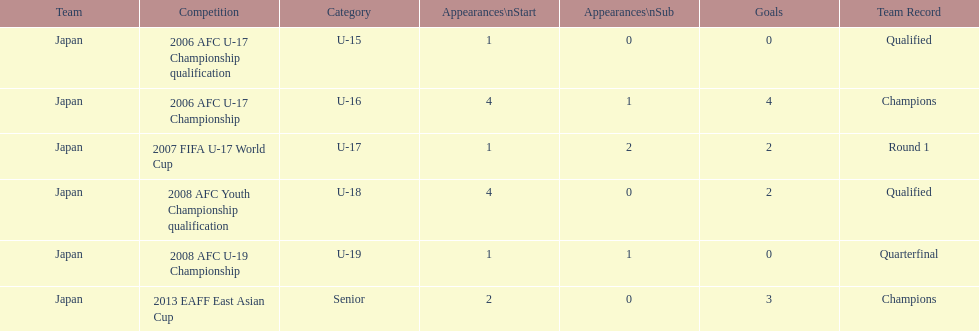In how many significant tournaments did yoichiro kakitani score more than 2 goals? 2. 